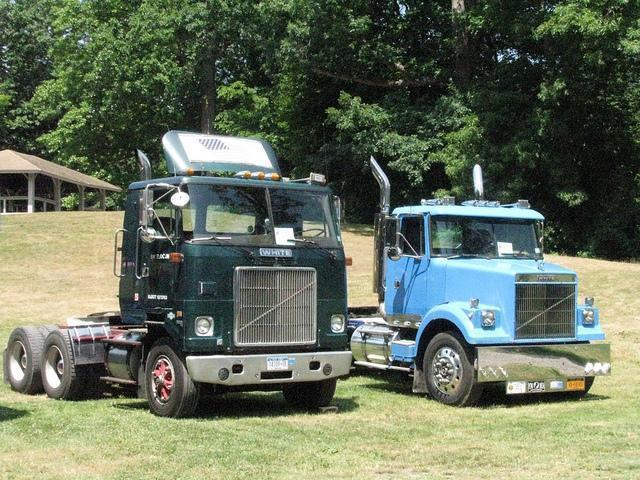How many wheels does the green truck have?
Give a very brief answer. 10. How many windshield wipers are there?
Give a very brief answer. 4. How many trucks can you see?
Give a very brief answer. 2. How many people are visible?
Give a very brief answer. 0. 